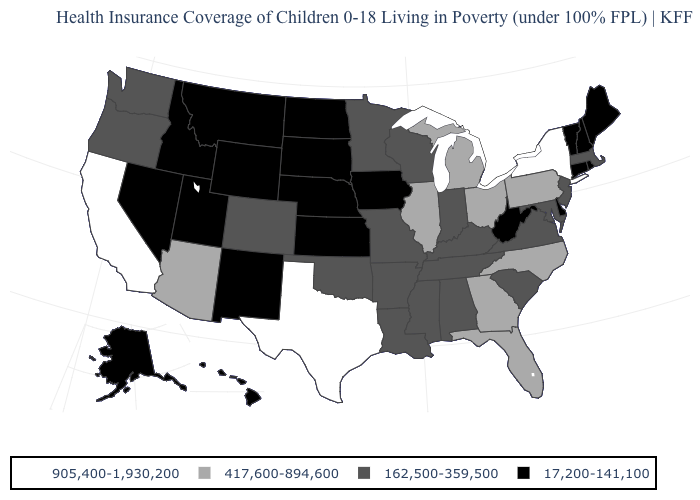What is the value of Ohio?
Answer briefly. 417,600-894,600. Name the states that have a value in the range 17,200-141,100?
Short answer required. Alaska, Connecticut, Delaware, Hawaii, Idaho, Iowa, Kansas, Maine, Montana, Nebraska, Nevada, New Hampshire, New Mexico, North Dakota, Rhode Island, South Dakota, Utah, Vermont, West Virginia, Wyoming. Does Pennsylvania have the same value as Arizona?
Give a very brief answer. Yes. Does California have the same value as New York?
Write a very short answer. Yes. Among the states that border New York , which have the highest value?
Give a very brief answer. Pennsylvania. What is the value of Connecticut?
Answer briefly. 17,200-141,100. Which states have the lowest value in the USA?
Give a very brief answer. Alaska, Connecticut, Delaware, Hawaii, Idaho, Iowa, Kansas, Maine, Montana, Nebraska, Nevada, New Hampshire, New Mexico, North Dakota, Rhode Island, South Dakota, Utah, Vermont, West Virginia, Wyoming. Among the states that border Oregon , does California have the highest value?
Quick response, please. Yes. What is the lowest value in the MidWest?
Give a very brief answer. 17,200-141,100. Among the states that border Washington , does Idaho have the highest value?
Keep it brief. No. Which states have the lowest value in the USA?
Concise answer only. Alaska, Connecticut, Delaware, Hawaii, Idaho, Iowa, Kansas, Maine, Montana, Nebraska, Nevada, New Hampshire, New Mexico, North Dakota, Rhode Island, South Dakota, Utah, Vermont, West Virginia, Wyoming. Does Texas have the highest value in the USA?
Write a very short answer. Yes. Name the states that have a value in the range 417,600-894,600?
Keep it brief. Arizona, Florida, Georgia, Illinois, Michigan, North Carolina, Ohio, Pennsylvania. Name the states that have a value in the range 162,500-359,500?
Short answer required. Alabama, Arkansas, Colorado, Indiana, Kentucky, Louisiana, Maryland, Massachusetts, Minnesota, Mississippi, Missouri, New Jersey, Oklahoma, Oregon, South Carolina, Tennessee, Virginia, Washington, Wisconsin. What is the lowest value in the South?
Be succinct. 17,200-141,100. 